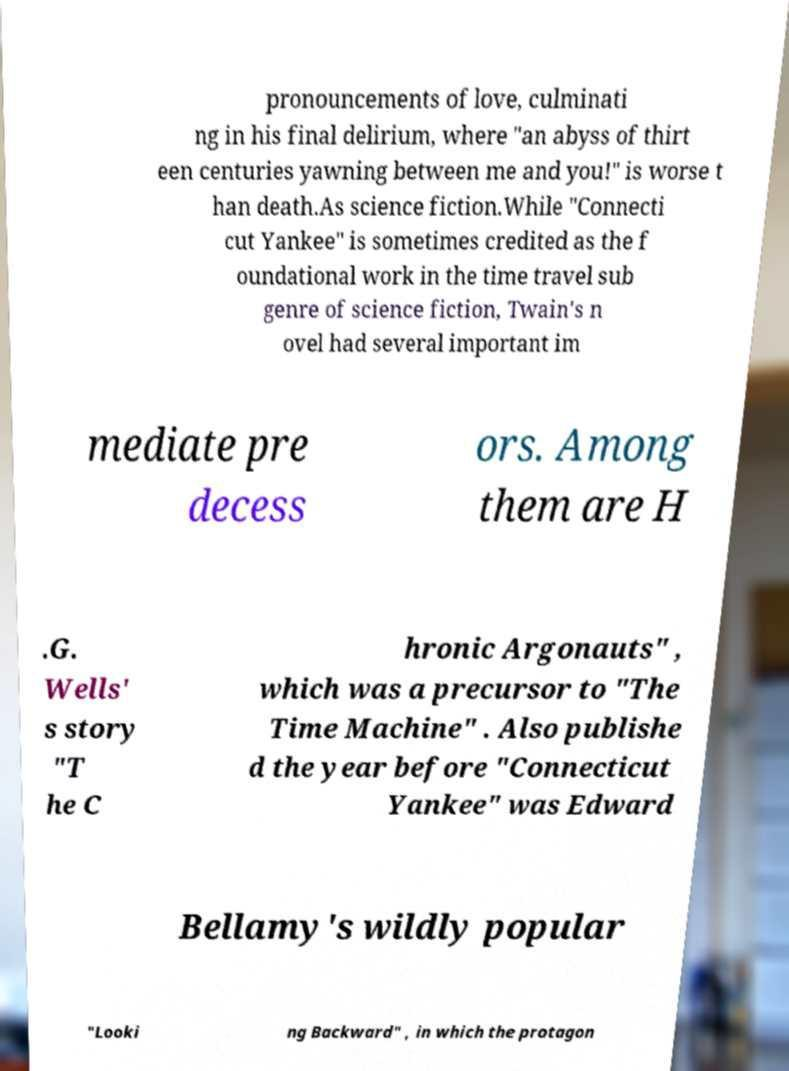Please identify and transcribe the text found in this image. pronouncements of love, culminati ng in his final delirium, where "an abyss of thirt een centuries yawning between me and you!" is worse t han death.As science fiction.While "Connecti cut Yankee" is sometimes credited as the f oundational work in the time travel sub genre of science fiction, Twain's n ovel had several important im mediate pre decess ors. Among them are H .G. Wells' s story "T he C hronic Argonauts" , which was a precursor to "The Time Machine" . Also publishe d the year before "Connecticut Yankee" was Edward Bellamy's wildly popular "Looki ng Backward" , in which the protagon 